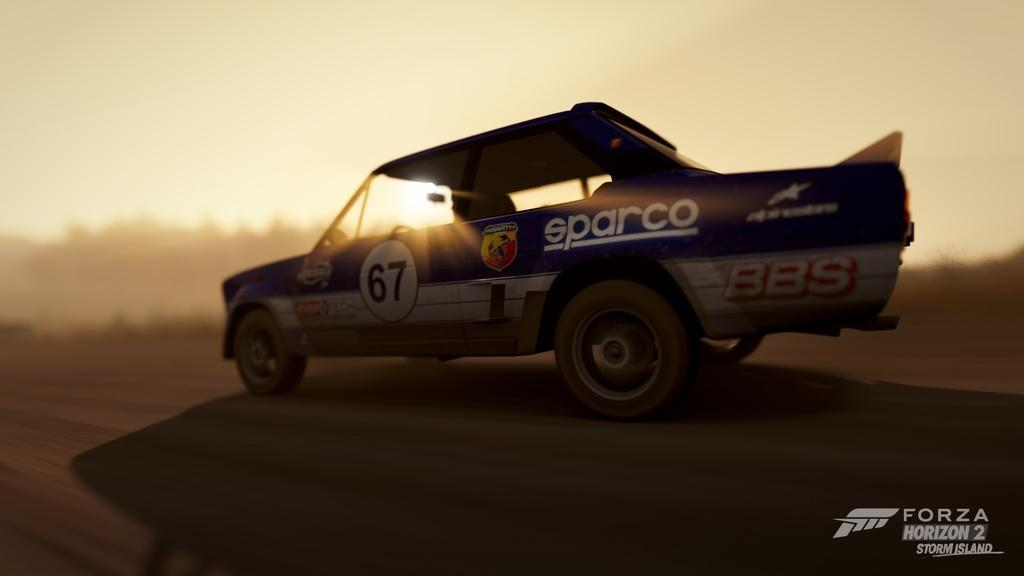What is the main subject of the image? The main subject of the image is a car. What is the car doing in the image? The car is moving on the road in the image. What can be seen in the background of the image? There is sky visible in the background of the image. Is there any additional information or markings on the image? Yes, there is a watermark in the bottom right side of the image. What type of drum can be heard playing in the image? There is no drum or sound present in the image; it is a still image of a moving car. 